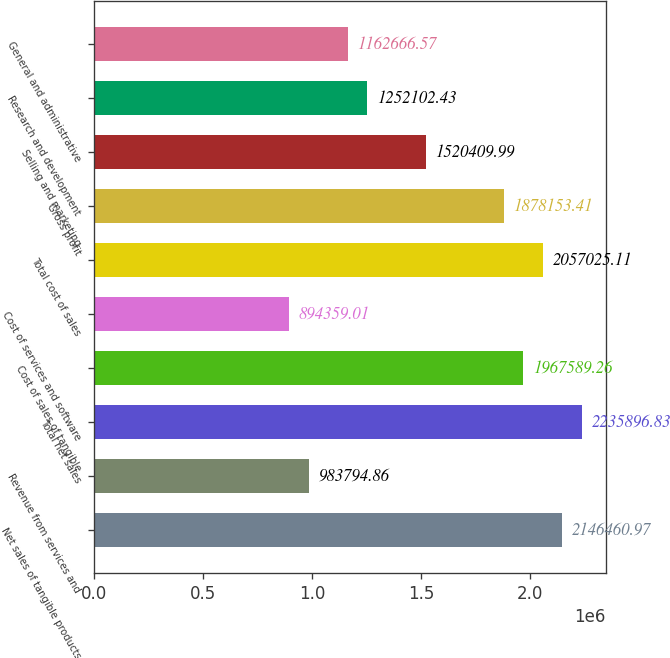Convert chart to OTSL. <chart><loc_0><loc_0><loc_500><loc_500><bar_chart><fcel>Net sales of tangible products<fcel>Revenue from services and<fcel>Total net sales<fcel>Cost of sales of tangible<fcel>Cost of services and software<fcel>Total cost of sales<fcel>Gross profit<fcel>Selling and marketing<fcel>Research and development<fcel>General and administrative<nl><fcel>2.14646e+06<fcel>983795<fcel>2.2359e+06<fcel>1.96759e+06<fcel>894359<fcel>2.05703e+06<fcel>1.87815e+06<fcel>1.52041e+06<fcel>1.2521e+06<fcel>1.16267e+06<nl></chart> 